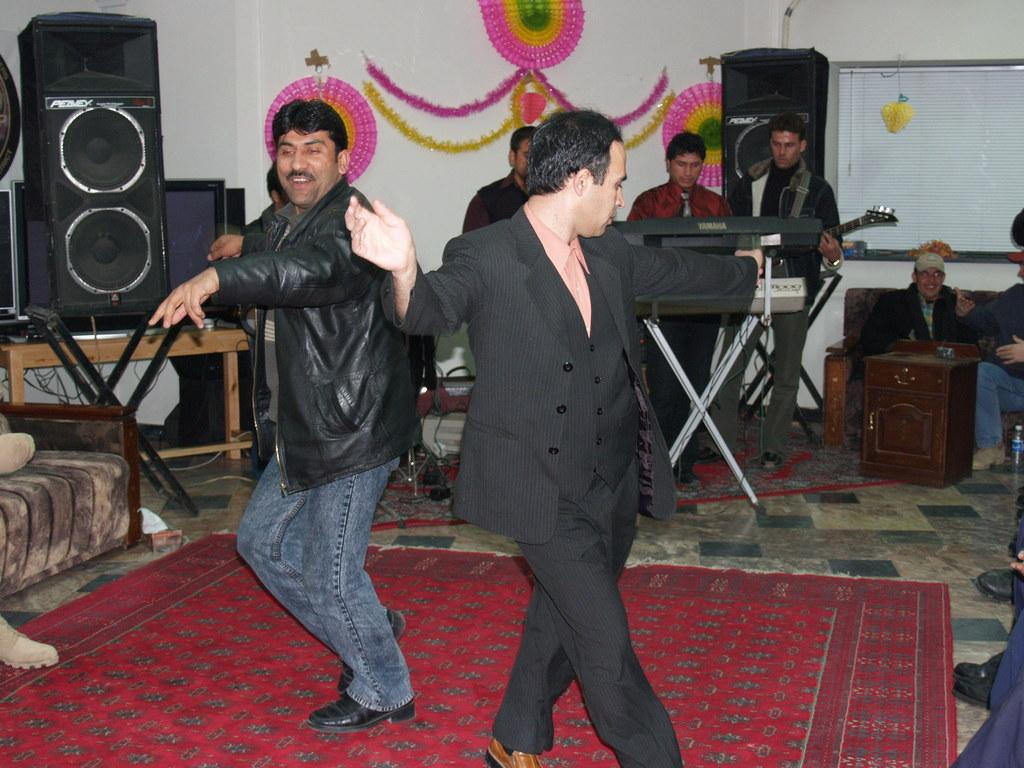What are the two men in the image doing? The two men in the image are dancing. Where are the men dancing? The men are dancing on the floor. What can be seen in the image that might be related to music? There are speakers visible in the image, and there are people playing musical instruments. What is visible in the background of the image? There is a wall in the background of the image. What type of berry is being used as a notebook in the image? There is no berry or notebook present in the image. 